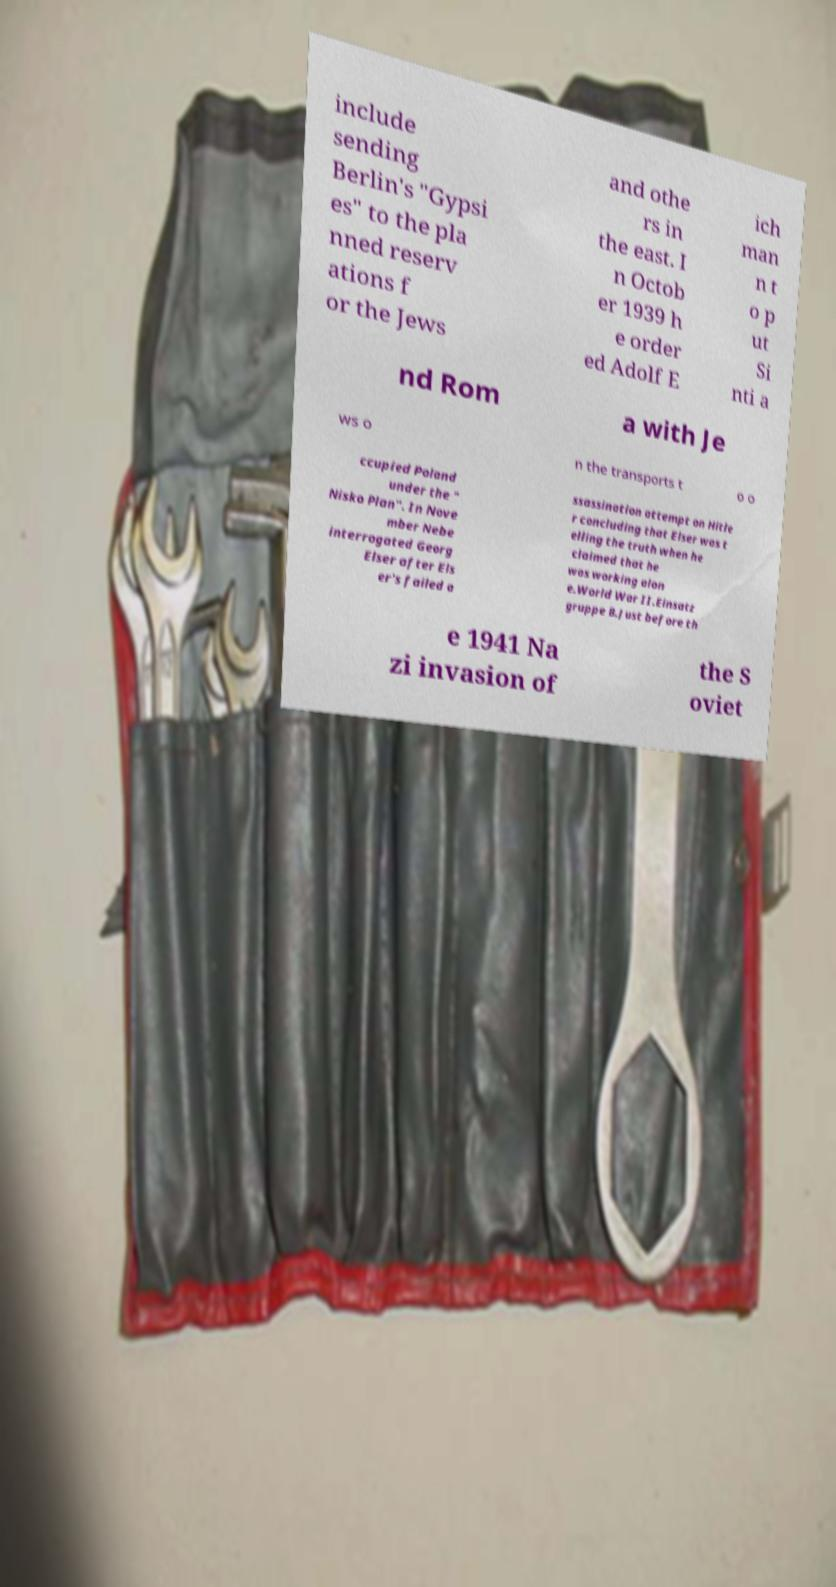For documentation purposes, I need the text within this image transcribed. Could you provide that? include sending Berlin's "Gypsi es" to the pla nned reserv ations f or the Jews and othe rs in the east. I n Octob er 1939 h e order ed Adolf E ich man n t o p ut Si nti a nd Rom a with Je ws o n the transports t o o ccupied Poland under the " Nisko Plan". In Nove mber Nebe interrogated Georg Elser after Els er's failed a ssassination attempt on Hitle r concluding that Elser was t elling the truth when he claimed that he was working alon e.World War II.Einsatz gruppe B.Just before th e 1941 Na zi invasion of the S oviet 